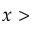Convert formula to latex. <formula><loc_0><loc_0><loc_500><loc_500>x ></formula> 